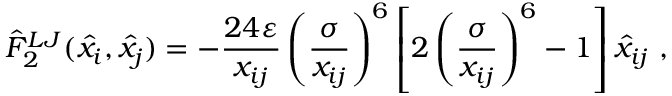Convert formula to latex. <formula><loc_0><loc_0><loc_500><loc_500>\hat { F } _ { 2 } ^ { L J } ( \hat { x _ { i } } , \hat { x _ { j } } ) = - \frac { 2 4 \varepsilon } { x _ { i j } } \left ( \frac { \sigma } { x _ { i j } } \right ) ^ { 6 } \left [ 2 \left ( \frac { \sigma } { x _ { i j } } \right ) ^ { 6 } - 1 \right ] \hat { x } _ { i j } ,</formula> 